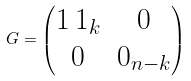<formula> <loc_0><loc_0><loc_500><loc_500>G = \begin{pmatrix} 1 \, 1 _ { k } & 0 \\ 0 & 0 _ { n - k } \end{pmatrix}</formula> 